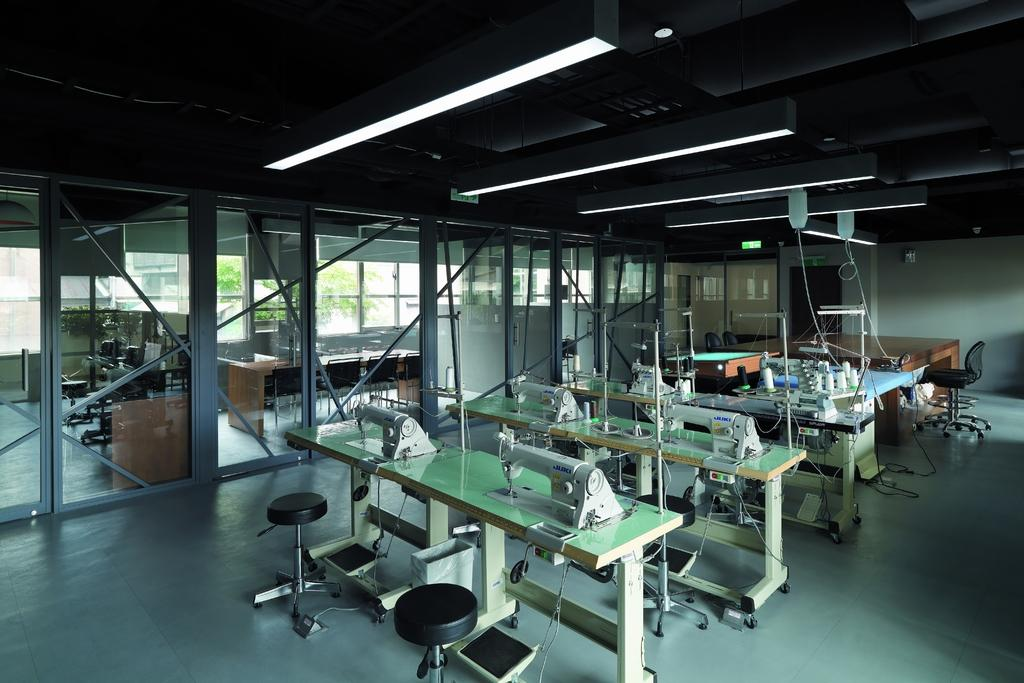What type of furniture is present in the image? There is a table and stools in the image. What is placed on the table? There are machines on the table. What can be seen in the background of the image? There is a chair and a wall in the background of the image. What is the source of light in the image? There are lights on the ceiling in the image. What type of food is being prepared on the machines in the image? There is no food or preparation of food visible in the image; it features machines on a table. What kind of treatment is being administered to the dogs in the image? There are no dogs present in the image, so no treatment can be observed. 